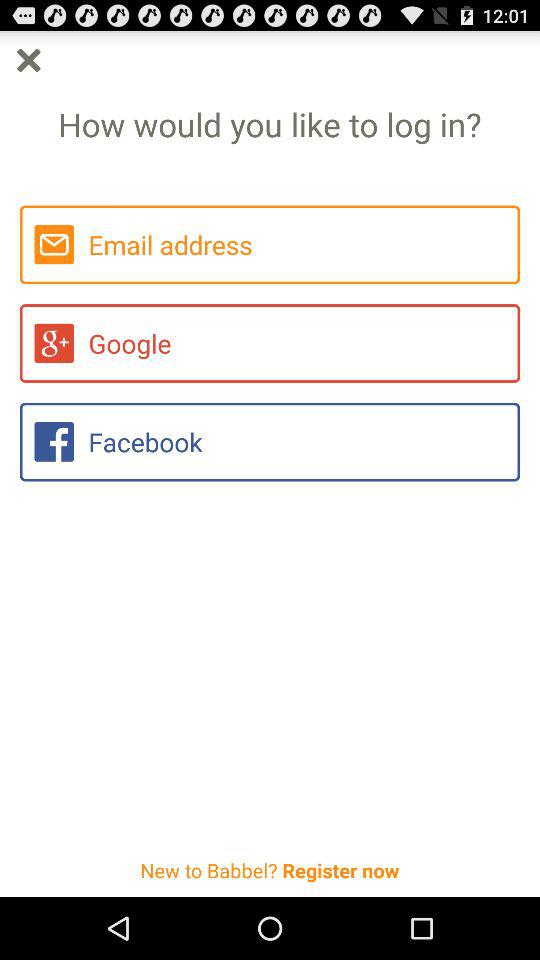What are the different options for logging in? The different options are "Email address", "Google" and "Facebook". 